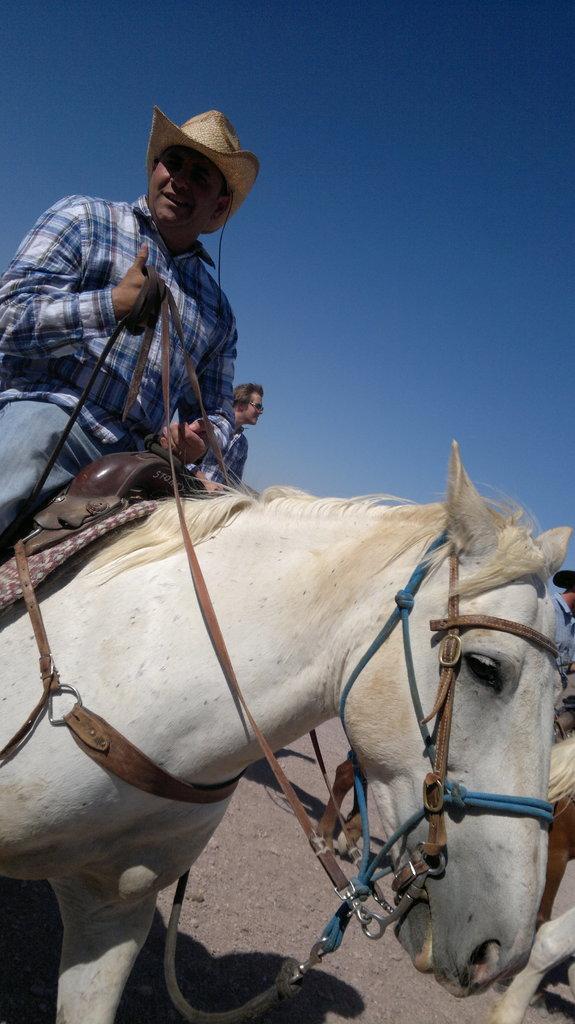In one or two sentences, can you explain what this image depicts? In this image on the left side there is one horse and on the horse there is one person who is sitting and he is wearing a cap it seems that he is riding and on the top there is sky and on the right side there is another horse and one person is there and in the middle there is another person. 